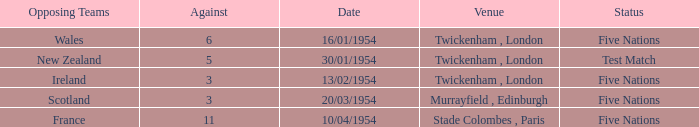What is the status when the against is 11? Five Nations. 